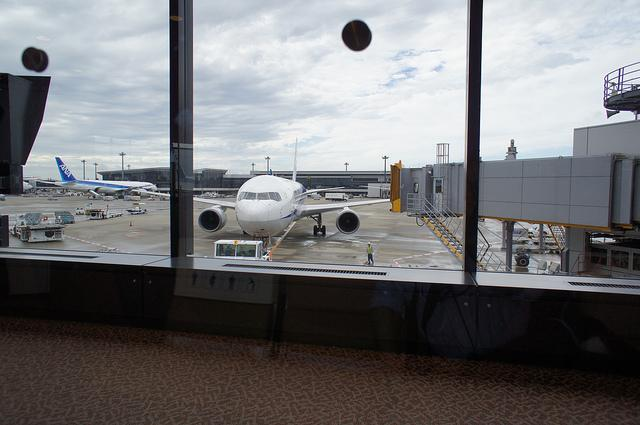Why does the man wear a yellow vest? visibility 